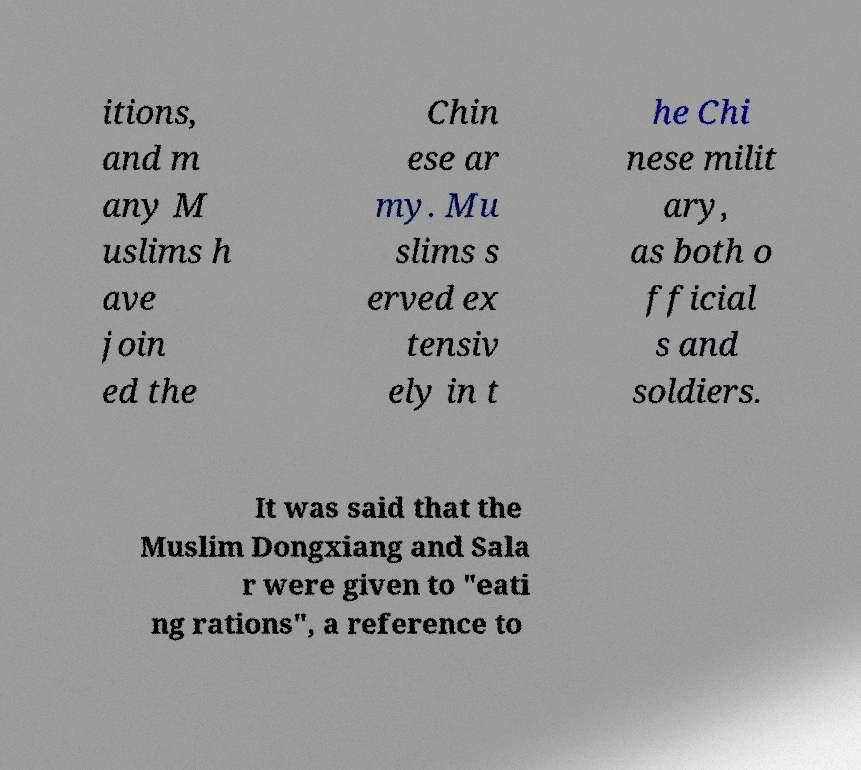There's text embedded in this image that I need extracted. Can you transcribe it verbatim? itions, and m any M uslims h ave join ed the Chin ese ar my. Mu slims s erved ex tensiv ely in t he Chi nese milit ary, as both o fficial s and soldiers. It was said that the Muslim Dongxiang and Sala r were given to "eati ng rations", a reference to 